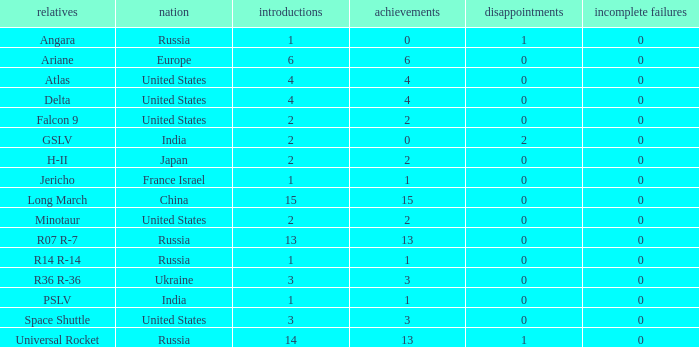What is the partial failure for the Country of russia, and a Failure larger than 0, and a Family of angara, and a Launch larger than 1? None. 